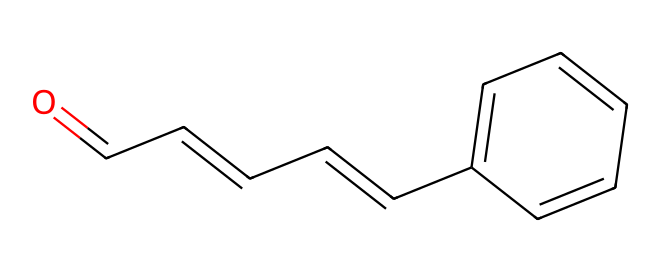What is the functional group present in cinnamaldehyde? The structure shows a carbonyl group (C=O) at the end of the carbon chain, which is characteristic of aldehydes.
Answer: aldehyde How many carbon atoms are in cinnamaldehyde? By counting the carbon atoms in the SMILES representation, there are 9 carbon atoms in total from both the straight chain and the aromatic ring.
Answer: 9 How many double bonds are present in this structure? The structure displays a total of 3 double bonds, 1 in the carbonyl group and 2 in the double bonds between carbon atoms in the chain.
Answer: 3 What is the molecular formula of cinnamaldehyde? By calculating the number of each type of atom from the structure, the molecular formula can be derived as C9H8O.
Answer: C9H8O Where in the structure is the carbonyl group located? The carbonyl group is located at the first carbon atom in the aldehyde functionality, which is indicated in the SMILES by the 'O=' at the start.
Answer: first carbon Is cinnamaldehyde saturated or unsaturated? The presence of double bonds in the carbon chain indicates that the compound is unsaturated.
Answer: unsaturated What characteristic scent does cinnamaldehyde impart in perfumes? Cinnamaldehyde is known for its sweet, spicy, cinnamon-like scent, which is a key feature in its use in fragrances.
Answer: cinnamon-like 